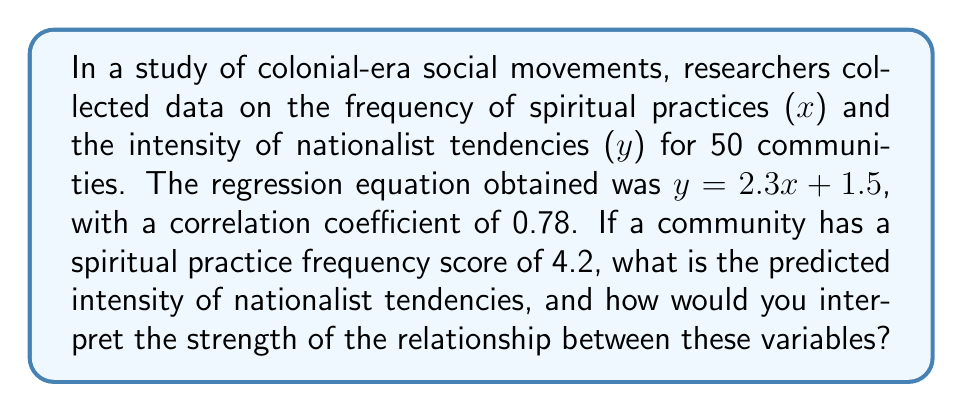Can you answer this question? 1. Given information:
   - Regression equation: $y = 2.3x + 1.5$
   - Correlation coefficient: $r = 0.78$
   - Spiritual practice frequency (x) = 4.2

2. To predict the intensity of nationalist tendencies (y), substitute x = 4.2 into the regression equation:
   $y = 2.3(4.2) + 1.5$
   $y = 9.66 + 1.5$
   $y = 11.16$

3. Interpreting the strength of the relationship:
   - The correlation coefficient (r) ranges from -1 to 1
   - $r = 0.78$ indicates a strong positive correlation
   - $r^2 = (0.78)^2 = 0.6084$
   - This means that approximately 60.84% of the variation in nationalist tendencies can be explained by the frequency of spiritual practices

4. In the context of colonial-era social movements:
   - There is a strong positive relationship between spiritual practices and nationalist tendencies
   - As the frequency of spiritual practices increases, the intensity of nationalist tendencies tends to increase as well
   - However, correlation does not imply causation, and other factors may influence this relationship
Answer: Predicted intensity: 11.16; Strong positive correlation (r = 0.78) 